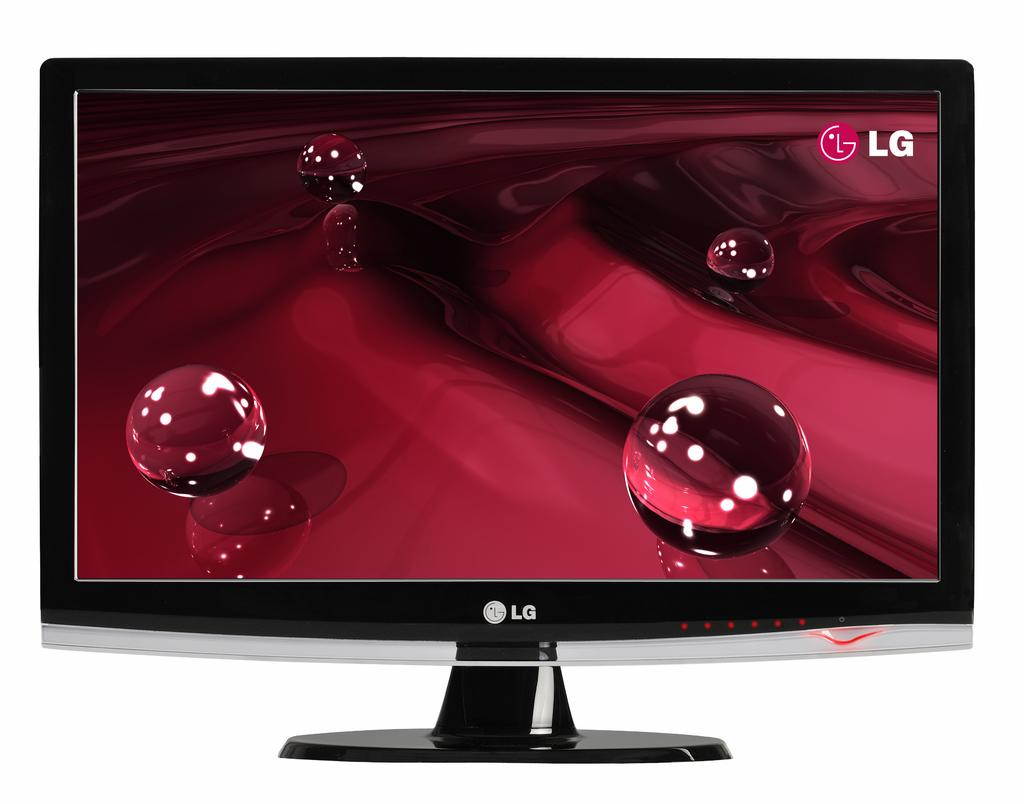<image>
Describe the image concisely. the letters LG written on the tv that is purple 